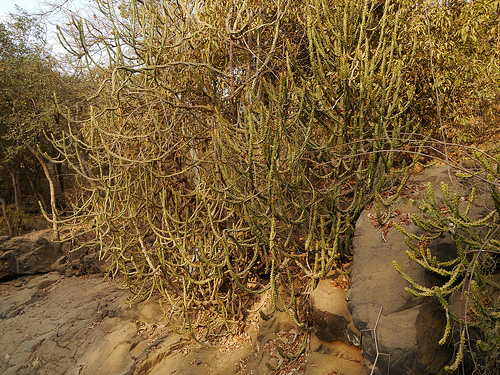<image>
Is the rock behind the plant? Yes. From this viewpoint, the rock is positioned behind the plant, with the plant partially or fully occluding the rock. 